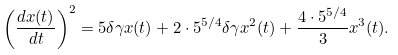<formula> <loc_0><loc_0><loc_500><loc_500>\left ( \frac { d x ( t ) } { d t } \right ) ^ { 2 } = 5 \delta \gamma x ( t ) + 2 \cdot 5 ^ { 5 / 4 } \delta \gamma x ^ { 2 } ( t ) + \frac { 4 \cdot 5 ^ { 5 / 4 } } { 3 } x ^ { 3 } ( t ) .</formula> 